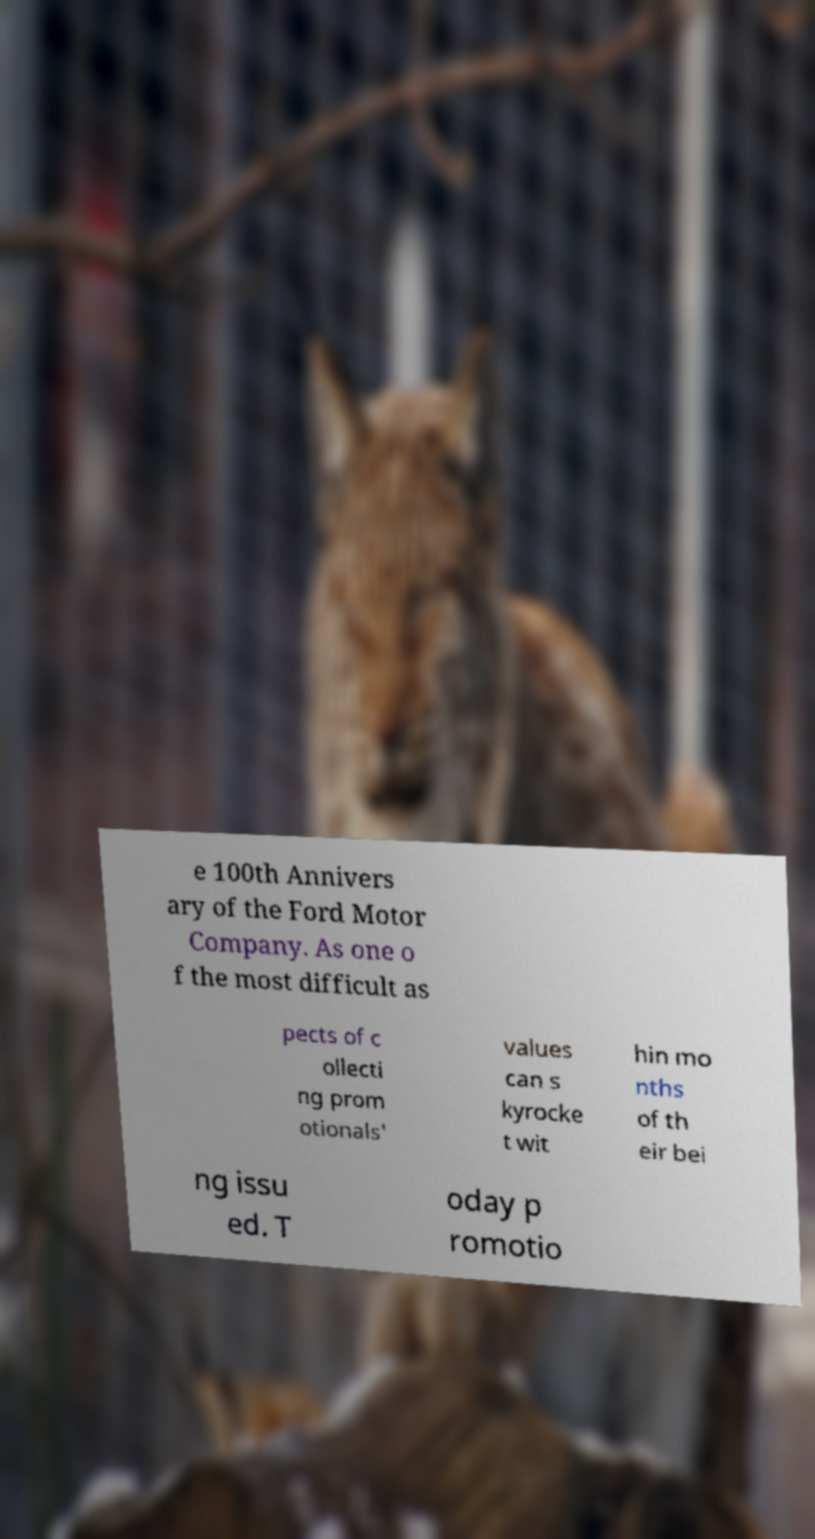For documentation purposes, I need the text within this image transcribed. Could you provide that? e 100th Annivers ary of the Ford Motor Company. As one o f the most difficult as pects of c ollecti ng prom otionals' values can s kyrocke t wit hin mo nths of th eir bei ng issu ed. T oday p romotio 